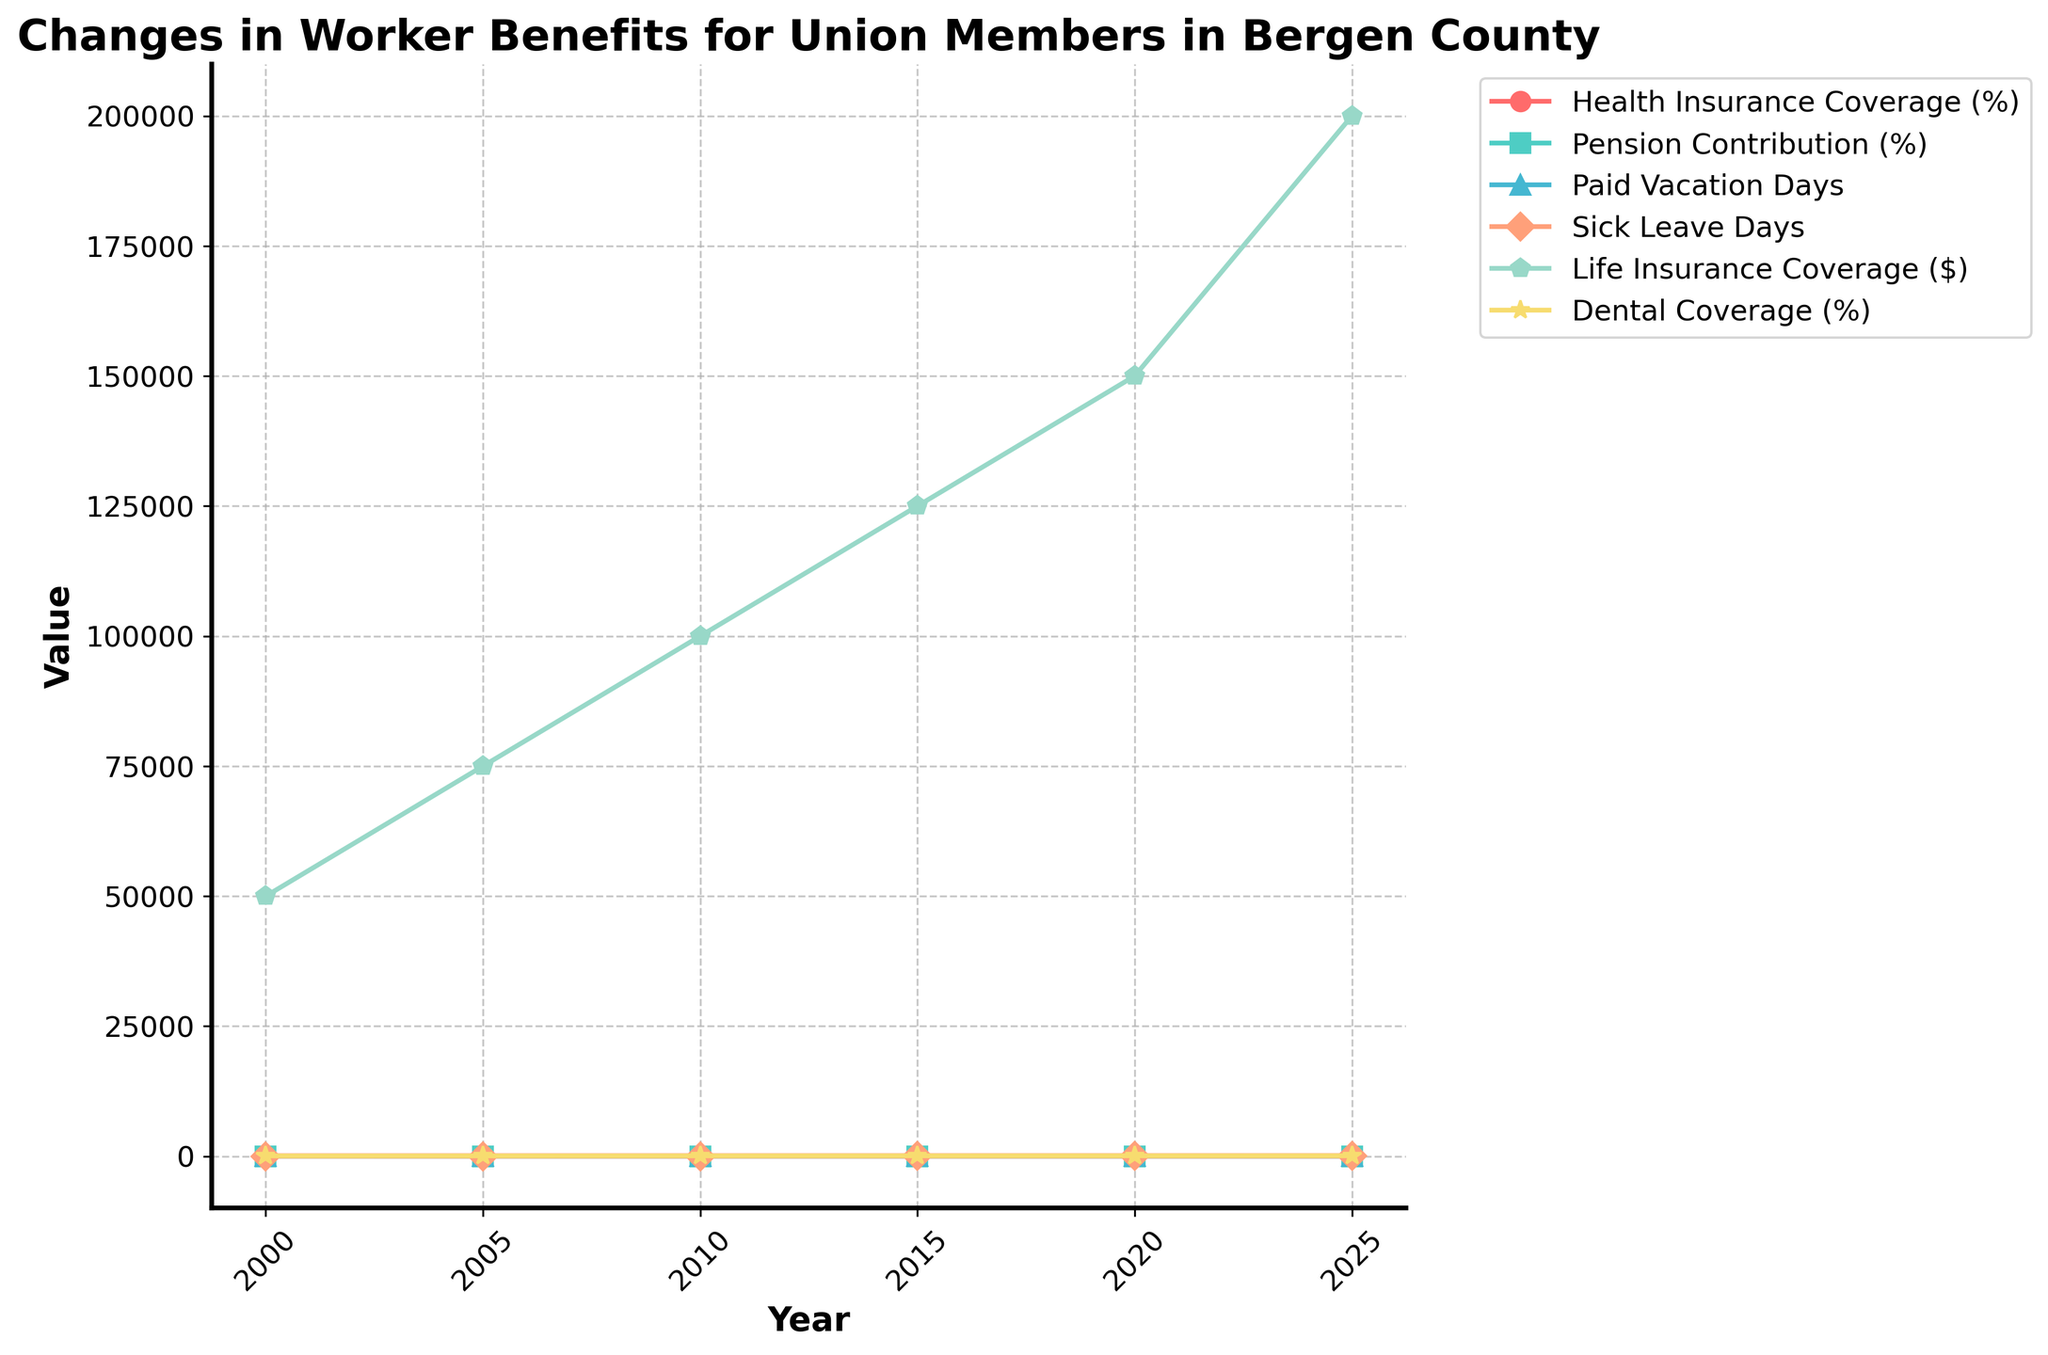what percentage did Health Insurance Coverage increase from 2000 to 2025? In 2000, Health Insurance Coverage was 85%, and in 2025 it was 96%. The increase is calculated as 96% - 85%.
Answer: 11% During which year did Pension Contribution reach 6.5%? By looking at the line for Pension Contribution, we can see it reaches 6.5% in the year 2020.
Answer: 2020 How many more Paid Vacation Days were there in 2025 compared to 2000? In 2000, there were 10 Paid Vacation Days, and in 2025, there were 20 Paid Vacation Days. The difference is 20 - 10.
Answer: 10 Between which years did Sick Leave Days increase the most? By examining the Sick Leave Days line, we see the highest increase between consecutive years occurs between 2020 (10 days) and 2025 (12 days). The increase is 2 days.
Answer: 2020 to 2025 What is the total Life Insurance Coverage increase from 2000 to 2025? In 2000, Life Insurance Coverage was $50,000, and in 2025, it was $200,000. The increase is $200,000 - $50,000.
Answer: $150,000 Which benefit had the highest percentage increase from 2000 to 2025? Calculate the percentage increase for each benefit. For Health Insurance Coverage, it's [(96-85)/85]*100 = 12.94%. For Pension Contribution, it's [(7-4.5)/4.5]*100 = 55.56%. For Dental Coverage, it's [(85-60)/60]*100 = 41.67%. The largest increase is in Pension Contribution.
Answer: Pension Contribution In what year did Dental Coverage first reach 70%? By following the line for Dental Coverage, we see it first reaches 70% in the year 2010.
Answer: 2010 How many years did it take for Paid Vacation Days to increase from 10 to 17 days? Paid Vacation Days started at 10 days in 2000 and reached 17 days in 2020. The number of years taken is 2020 - 2000.
Answer: 20 years What is the average Sick Leave Days from 2000 to 2025? The Sick Leave Days for the years listed are 5, 6, 7, 8, 10, and 12. The sum of these is 48. The average is 48 / 6.
Answer: 8 Which benefit remained below 10% throughout the given time period? By looking at all the lines, we see that Pension Contribution starts at 4.5% and ends at 7.0%, which is always below 10%.
Answer: Pension Contribution 